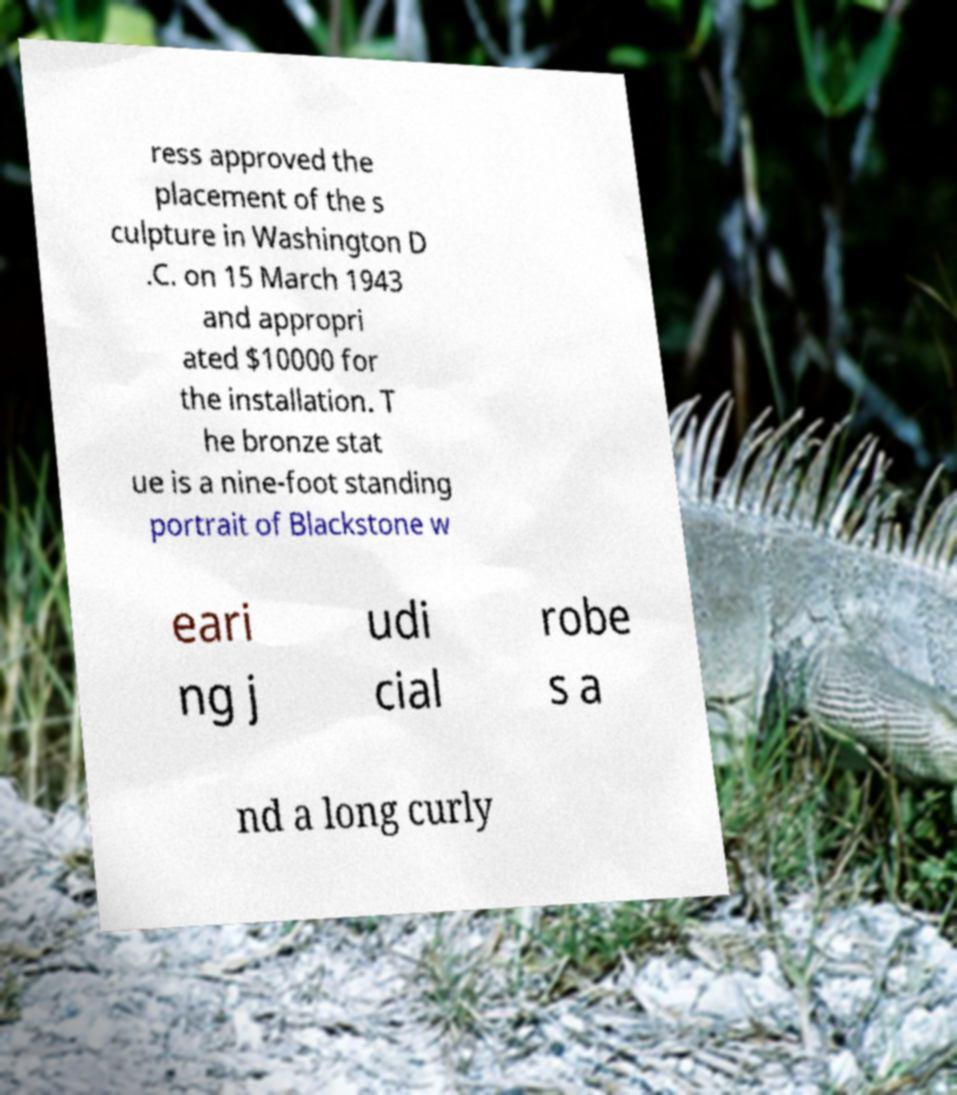What messages or text are displayed in this image? I need them in a readable, typed format. ress approved the placement of the s culpture in Washington D .C. on 15 March 1943 and appropri ated $10000 for the installation. T he bronze stat ue is a nine-foot standing portrait of Blackstone w eari ng j udi cial robe s a nd a long curly 